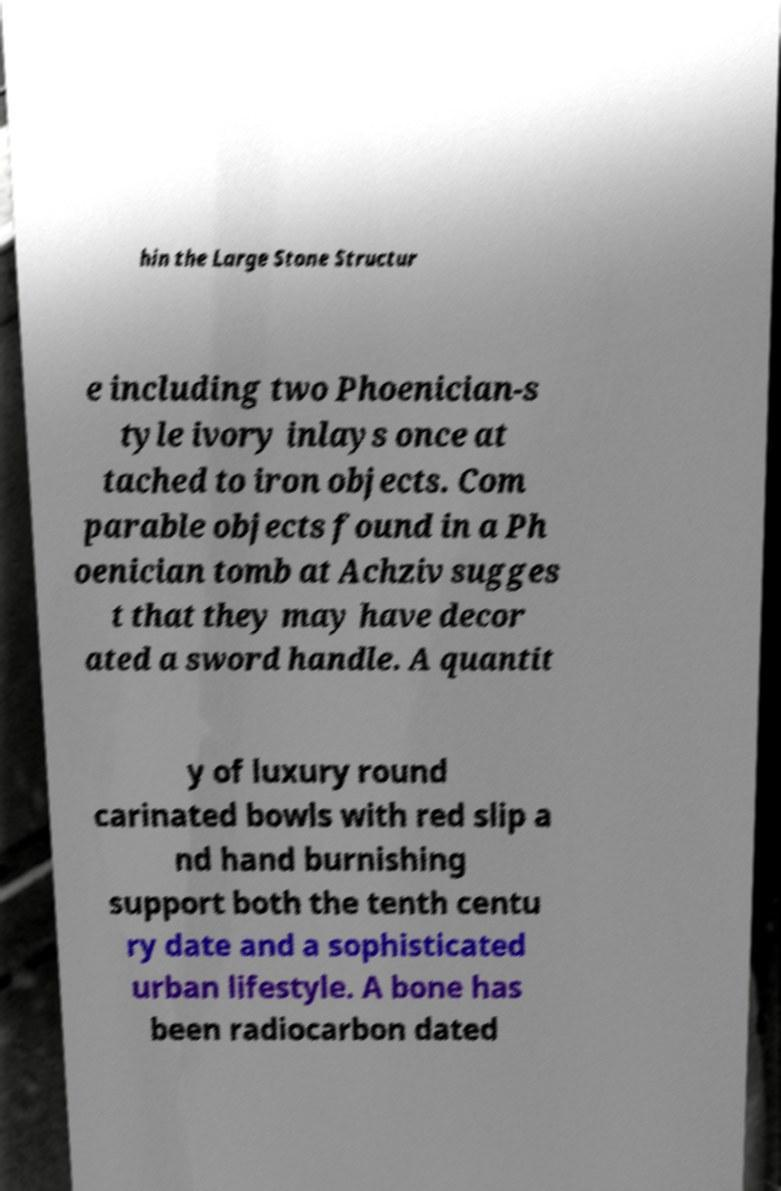What messages or text are displayed in this image? I need them in a readable, typed format. hin the Large Stone Structur e including two Phoenician-s tyle ivory inlays once at tached to iron objects. Com parable objects found in a Ph oenician tomb at Achziv sugges t that they may have decor ated a sword handle. A quantit y of luxury round carinated bowls with red slip a nd hand burnishing support both the tenth centu ry date and a sophisticated urban lifestyle. A bone has been radiocarbon dated 